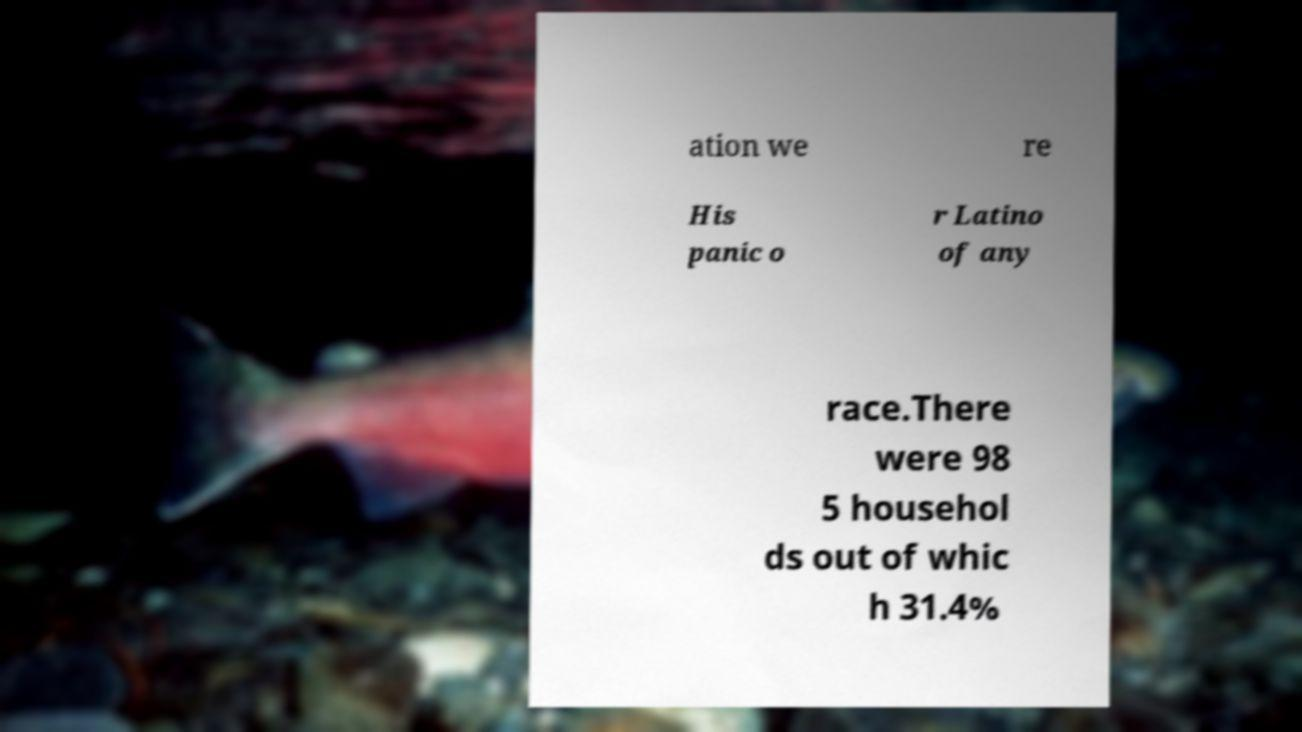There's text embedded in this image that I need extracted. Can you transcribe it verbatim? ation we re His panic o r Latino of any race.There were 98 5 househol ds out of whic h 31.4% 